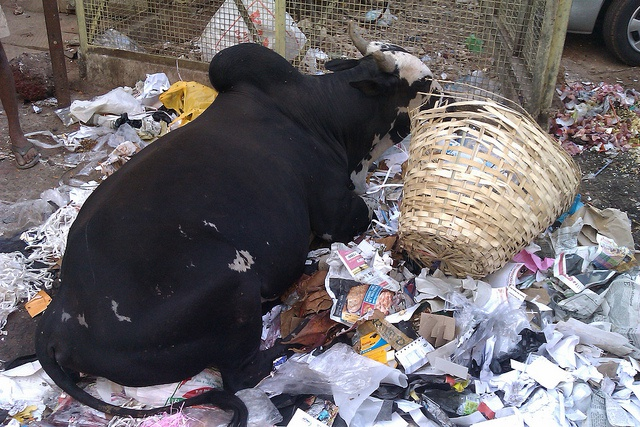Describe the objects in this image and their specific colors. I can see a cow in gray, black, darkgray, and lavender tones in this image. 